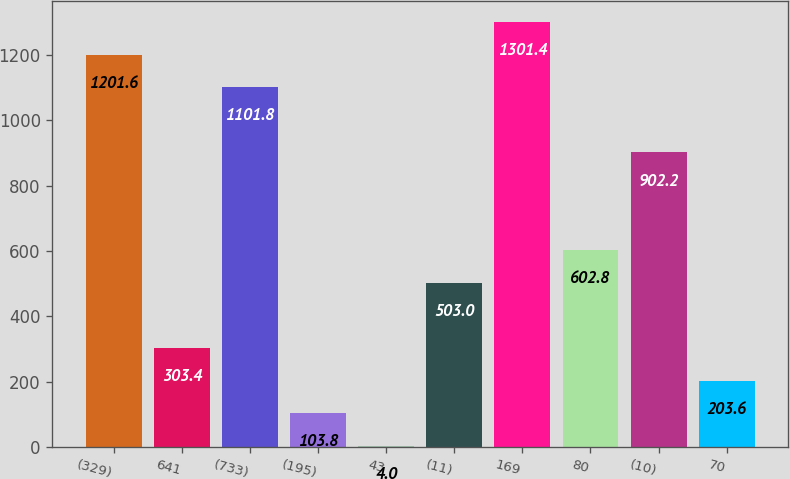Convert chart. <chart><loc_0><loc_0><loc_500><loc_500><bar_chart><fcel>(329)<fcel>641<fcel>(733)<fcel>(195)<fcel>43<fcel>(11)<fcel>169<fcel>80<fcel>(10)<fcel>70<nl><fcel>1201.6<fcel>303.4<fcel>1101.8<fcel>103.8<fcel>4<fcel>503<fcel>1301.4<fcel>602.8<fcel>902.2<fcel>203.6<nl></chart> 